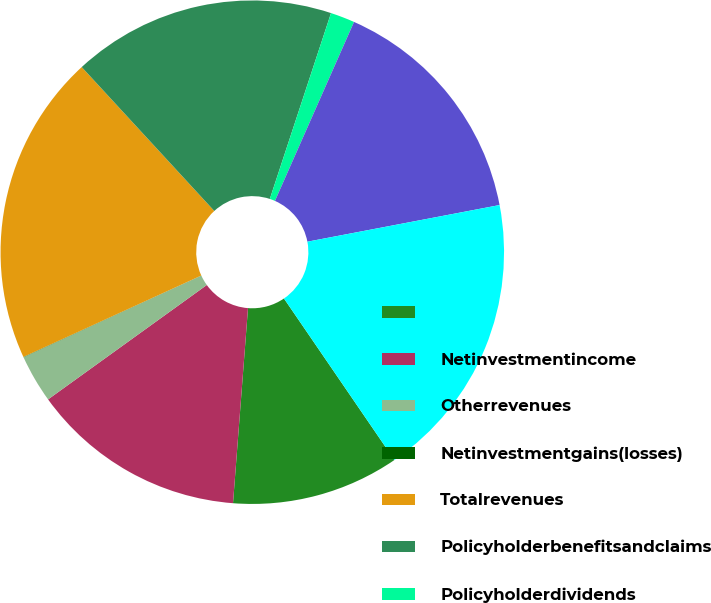<chart> <loc_0><loc_0><loc_500><loc_500><pie_chart><ecel><fcel>Netinvestmentincome<fcel>Otherrevenues<fcel>Netinvestmentgains(losses)<fcel>Totalrevenues<fcel>Policyholderbenefitsandclaims<fcel>Policyholderdividends<fcel>Otherexpenses<fcel>Totalexpenses<nl><fcel>10.77%<fcel>13.84%<fcel>3.09%<fcel>0.02%<fcel>19.98%<fcel>16.91%<fcel>1.56%<fcel>15.38%<fcel>18.45%<nl></chart> 